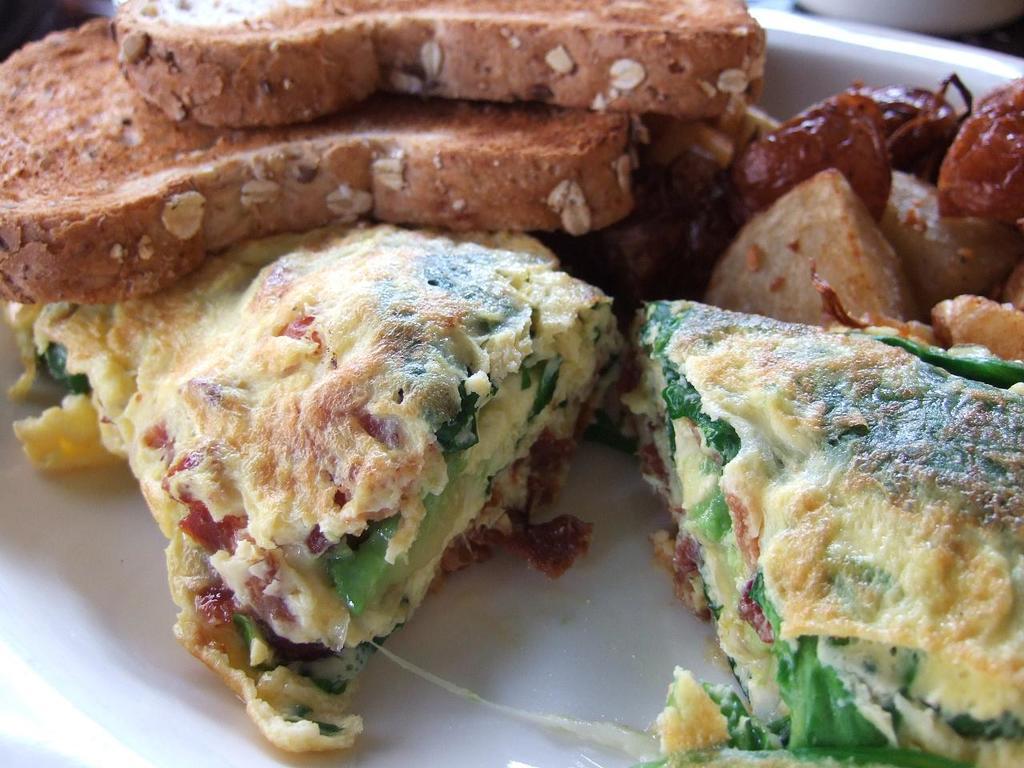Could you give a brief overview of what you see in this image? In this picture there is a plate, in the plate there are variety of dishes. 